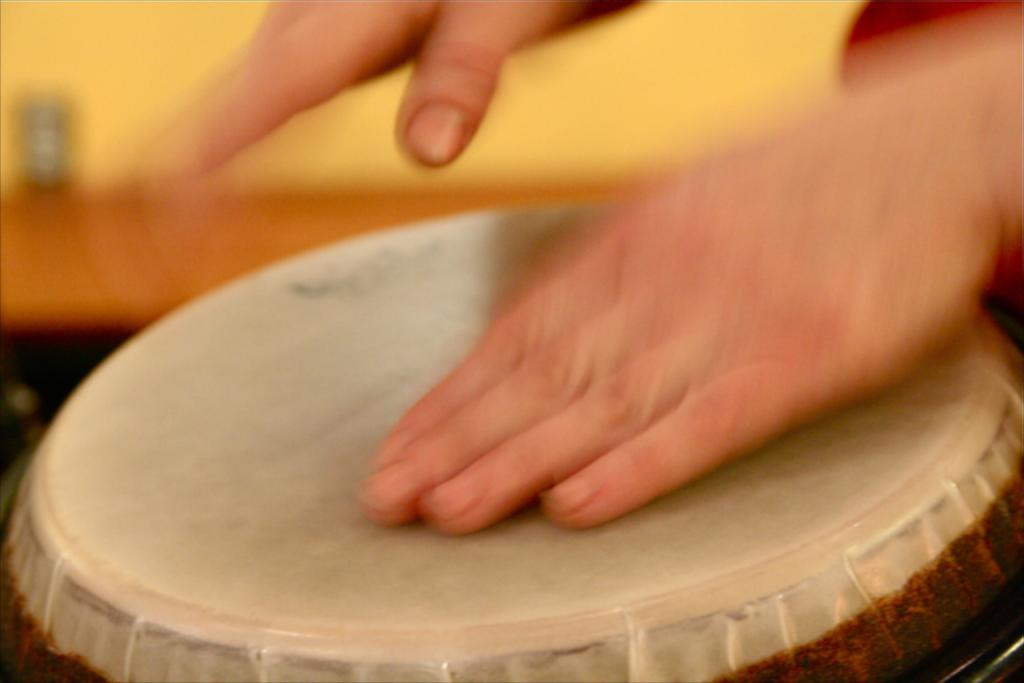What is the main subject of the image? There is a person in the image. What is the person doing in the image? The person is playing a tabla. Can you describe the background of the image? The background of the image is blurry. What type of rice can be seen in the image? There is no rice present in the image. Is the person in the image embarking on a voyage? There is no indication of a voyage in the image; the person is simply playing a tabla. 